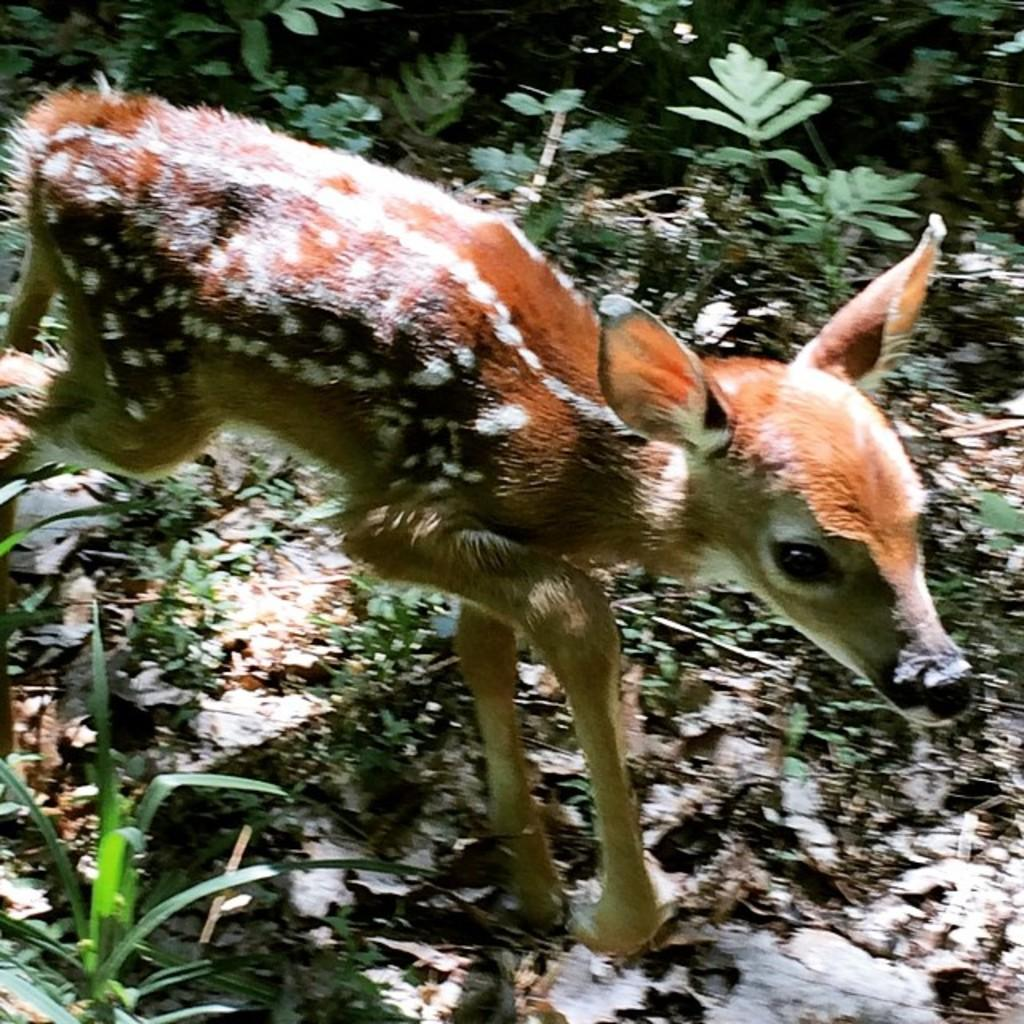What animal can be seen in the image? There is a deer in the image. What is the deer doing in the image? The deer is walking. What can be seen on the ground in the image? There are leaves on the ground in the image. Where might this image have been taken? The image appears to be taken in a forest. What type of bead is hanging from the deer's collar in the image? There is no bead or collar present on the deer in the image. Is the deer sitting on a cushion in the image? The image does not show the deer sitting on a cushion; the deer is walking. 